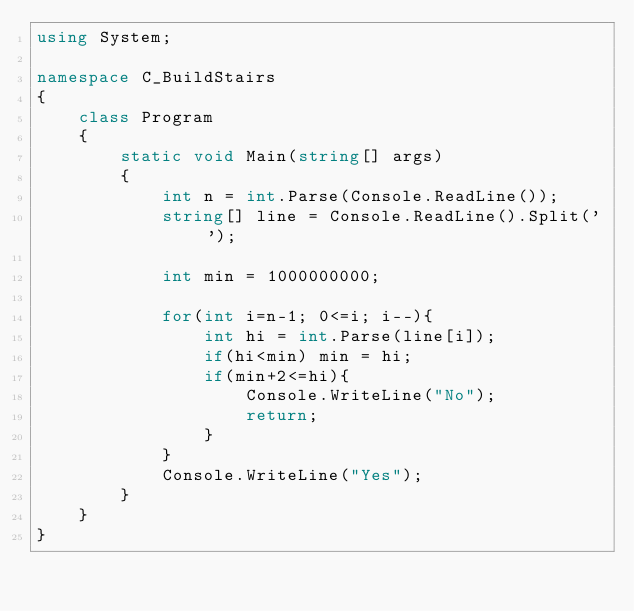Convert code to text. <code><loc_0><loc_0><loc_500><loc_500><_C#_>using System;

namespace C_BuildStairs
{
    class Program
    {
        static void Main(string[] args)
        {
            int n = int.Parse(Console.ReadLine());
            string[] line = Console.ReadLine().Split(' ');

            int min = 1000000000;

            for(int i=n-1; 0<=i; i--){
                int hi = int.Parse(line[i]);
                if(hi<min) min = hi;
                if(min+2<=hi){
                    Console.WriteLine("No");
                    return;
                }
            }
            Console.WriteLine("Yes");
        }
    }
}
</code> 